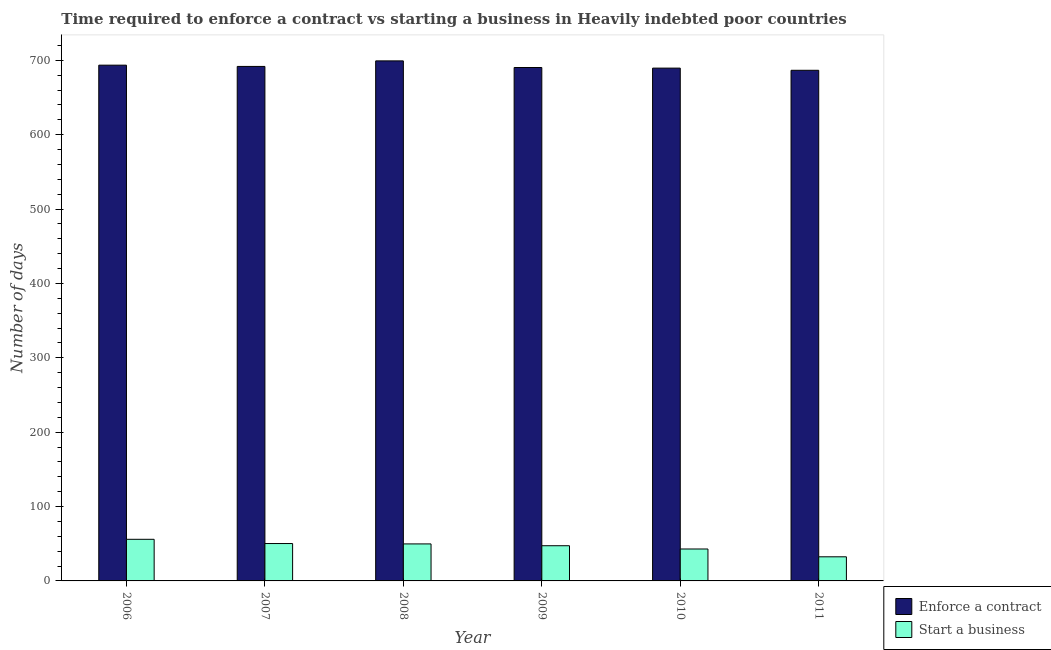How many different coloured bars are there?
Your response must be concise. 2. Are the number of bars per tick equal to the number of legend labels?
Provide a short and direct response. Yes. Are the number of bars on each tick of the X-axis equal?
Ensure brevity in your answer.  Yes. How many bars are there on the 2nd tick from the right?
Make the answer very short. 2. In how many cases, is the number of bars for a given year not equal to the number of legend labels?
Give a very brief answer. 0. What is the number of days to enforece a contract in 2007?
Ensure brevity in your answer.  691.74. Across all years, what is the maximum number of days to start a business?
Ensure brevity in your answer.  55.95. Across all years, what is the minimum number of days to start a business?
Your answer should be compact. 32.43. In which year was the number of days to start a business maximum?
Offer a terse response. 2006. What is the total number of days to enforece a contract in the graph?
Ensure brevity in your answer.  4150.71. What is the difference between the number of days to start a business in 2008 and that in 2009?
Provide a short and direct response. 2.45. What is the difference between the number of days to enforece a contract in 2010 and the number of days to start a business in 2007?
Provide a short and direct response. -2.26. What is the average number of days to start a business per year?
Make the answer very short. 46.44. In the year 2010, what is the difference between the number of days to enforece a contract and number of days to start a business?
Keep it short and to the point. 0. In how many years, is the number of days to enforece a contract greater than 140 days?
Ensure brevity in your answer.  6. What is the ratio of the number of days to enforece a contract in 2009 to that in 2011?
Provide a short and direct response. 1.01. Is the number of days to start a business in 2008 less than that in 2009?
Your answer should be compact. No. What is the difference between the highest and the second highest number of days to start a business?
Your answer should be very brief. 5.68. What is the difference between the highest and the lowest number of days to start a business?
Provide a succinct answer. 23.51. In how many years, is the number of days to enforece a contract greater than the average number of days to enforece a contract taken over all years?
Your response must be concise. 2. Is the sum of the number of days to start a business in 2008 and 2009 greater than the maximum number of days to enforece a contract across all years?
Your answer should be very brief. Yes. What does the 2nd bar from the left in 2010 represents?
Offer a very short reply. Start a business. What does the 2nd bar from the right in 2008 represents?
Ensure brevity in your answer.  Enforce a contract. How many bars are there?
Offer a very short reply. 12. Are all the bars in the graph horizontal?
Keep it short and to the point. No. How many years are there in the graph?
Your answer should be compact. 6. What is the difference between two consecutive major ticks on the Y-axis?
Ensure brevity in your answer.  100. Are the values on the major ticks of Y-axis written in scientific E-notation?
Offer a terse response. No. Where does the legend appear in the graph?
Ensure brevity in your answer.  Bottom right. How are the legend labels stacked?
Offer a terse response. Vertical. What is the title of the graph?
Keep it short and to the point. Time required to enforce a contract vs starting a business in Heavily indebted poor countries. Does "All education staff compensation" appear as one of the legend labels in the graph?
Offer a terse response. No. What is the label or title of the X-axis?
Your answer should be very brief. Year. What is the label or title of the Y-axis?
Provide a short and direct response. Number of days. What is the Number of days in Enforce a contract in 2006?
Your answer should be compact. 693.45. What is the Number of days of Start a business in 2006?
Your answer should be very brief. 55.95. What is the Number of days in Enforce a contract in 2007?
Provide a short and direct response. 691.74. What is the Number of days of Start a business in 2007?
Ensure brevity in your answer.  50.26. What is the Number of days in Enforce a contract in 2008?
Provide a succinct answer. 699.21. What is the Number of days of Start a business in 2008?
Your response must be concise. 49.76. What is the Number of days in Enforce a contract in 2009?
Ensure brevity in your answer.  690.29. What is the Number of days in Start a business in 2009?
Provide a succinct answer. 47.32. What is the Number of days in Enforce a contract in 2010?
Ensure brevity in your answer.  689.47. What is the Number of days in Start a business in 2010?
Your response must be concise. 42.92. What is the Number of days in Enforce a contract in 2011?
Make the answer very short. 686.55. What is the Number of days of Start a business in 2011?
Give a very brief answer. 32.43. Across all years, what is the maximum Number of days in Enforce a contract?
Your answer should be compact. 699.21. Across all years, what is the maximum Number of days of Start a business?
Ensure brevity in your answer.  55.95. Across all years, what is the minimum Number of days in Enforce a contract?
Ensure brevity in your answer.  686.55. Across all years, what is the minimum Number of days in Start a business?
Your answer should be compact. 32.43. What is the total Number of days of Enforce a contract in the graph?
Keep it short and to the point. 4150.71. What is the total Number of days of Start a business in the graph?
Ensure brevity in your answer.  278.64. What is the difference between the Number of days of Enforce a contract in 2006 and that in 2007?
Your response must be concise. 1.71. What is the difference between the Number of days of Start a business in 2006 and that in 2007?
Give a very brief answer. 5.68. What is the difference between the Number of days of Enforce a contract in 2006 and that in 2008?
Ensure brevity in your answer.  -5.76. What is the difference between the Number of days of Start a business in 2006 and that in 2008?
Provide a short and direct response. 6.18. What is the difference between the Number of days of Enforce a contract in 2006 and that in 2009?
Your answer should be very brief. 3.16. What is the difference between the Number of days in Start a business in 2006 and that in 2009?
Make the answer very short. 8.63. What is the difference between the Number of days of Enforce a contract in 2006 and that in 2010?
Provide a short and direct response. 3.97. What is the difference between the Number of days in Start a business in 2006 and that in 2010?
Offer a very short reply. 13.03. What is the difference between the Number of days in Enforce a contract in 2006 and that in 2011?
Give a very brief answer. 6.89. What is the difference between the Number of days of Start a business in 2006 and that in 2011?
Provide a succinct answer. 23.51. What is the difference between the Number of days of Enforce a contract in 2007 and that in 2008?
Keep it short and to the point. -7.47. What is the difference between the Number of days in Enforce a contract in 2007 and that in 2009?
Your answer should be very brief. 1.45. What is the difference between the Number of days of Start a business in 2007 and that in 2009?
Provide a succinct answer. 2.95. What is the difference between the Number of days of Enforce a contract in 2007 and that in 2010?
Provide a succinct answer. 2.26. What is the difference between the Number of days in Start a business in 2007 and that in 2010?
Offer a terse response. 7.34. What is the difference between the Number of days in Enforce a contract in 2007 and that in 2011?
Your answer should be compact. 5.18. What is the difference between the Number of days in Start a business in 2007 and that in 2011?
Ensure brevity in your answer.  17.83. What is the difference between the Number of days in Enforce a contract in 2008 and that in 2009?
Provide a succinct answer. 8.92. What is the difference between the Number of days of Start a business in 2008 and that in 2009?
Your answer should be very brief. 2.45. What is the difference between the Number of days of Enforce a contract in 2008 and that in 2010?
Offer a very short reply. 9.74. What is the difference between the Number of days of Start a business in 2008 and that in 2010?
Offer a very short reply. 6.84. What is the difference between the Number of days in Enforce a contract in 2008 and that in 2011?
Your answer should be compact. 12.66. What is the difference between the Number of days in Start a business in 2008 and that in 2011?
Offer a terse response. 17.33. What is the difference between the Number of days of Enforce a contract in 2009 and that in 2010?
Your answer should be very brief. 0.82. What is the difference between the Number of days of Start a business in 2009 and that in 2010?
Give a very brief answer. 4.39. What is the difference between the Number of days in Enforce a contract in 2009 and that in 2011?
Your answer should be compact. 3.74. What is the difference between the Number of days in Start a business in 2009 and that in 2011?
Your response must be concise. 14.88. What is the difference between the Number of days of Enforce a contract in 2010 and that in 2011?
Ensure brevity in your answer.  2.92. What is the difference between the Number of days in Start a business in 2010 and that in 2011?
Your answer should be compact. 10.49. What is the difference between the Number of days in Enforce a contract in 2006 and the Number of days in Start a business in 2007?
Offer a terse response. 643.18. What is the difference between the Number of days in Enforce a contract in 2006 and the Number of days in Start a business in 2008?
Ensure brevity in your answer.  643.68. What is the difference between the Number of days of Enforce a contract in 2006 and the Number of days of Start a business in 2009?
Your answer should be very brief. 646.13. What is the difference between the Number of days of Enforce a contract in 2006 and the Number of days of Start a business in 2010?
Your response must be concise. 650.53. What is the difference between the Number of days of Enforce a contract in 2006 and the Number of days of Start a business in 2011?
Your answer should be very brief. 661.01. What is the difference between the Number of days in Enforce a contract in 2007 and the Number of days in Start a business in 2008?
Your response must be concise. 641.97. What is the difference between the Number of days of Enforce a contract in 2007 and the Number of days of Start a business in 2009?
Your response must be concise. 644.42. What is the difference between the Number of days in Enforce a contract in 2007 and the Number of days in Start a business in 2010?
Offer a terse response. 648.82. What is the difference between the Number of days of Enforce a contract in 2007 and the Number of days of Start a business in 2011?
Make the answer very short. 659.3. What is the difference between the Number of days of Enforce a contract in 2008 and the Number of days of Start a business in 2009?
Offer a terse response. 651.89. What is the difference between the Number of days of Enforce a contract in 2008 and the Number of days of Start a business in 2010?
Your answer should be very brief. 656.29. What is the difference between the Number of days in Enforce a contract in 2008 and the Number of days in Start a business in 2011?
Offer a very short reply. 666.78. What is the difference between the Number of days of Enforce a contract in 2009 and the Number of days of Start a business in 2010?
Provide a short and direct response. 647.37. What is the difference between the Number of days of Enforce a contract in 2009 and the Number of days of Start a business in 2011?
Give a very brief answer. 657.86. What is the difference between the Number of days of Enforce a contract in 2010 and the Number of days of Start a business in 2011?
Make the answer very short. 657.04. What is the average Number of days of Enforce a contract per year?
Give a very brief answer. 691.79. What is the average Number of days of Start a business per year?
Make the answer very short. 46.44. In the year 2006, what is the difference between the Number of days in Enforce a contract and Number of days in Start a business?
Your answer should be compact. 637.5. In the year 2007, what is the difference between the Number of days of Enforce a contract and Number of days of Start a business?
Your answer should be very brief. 641.47. In the year 2008, what is the difference between the Number of days in Enforce a contract and Number of days in Start a business?
Provide a succinct answer. 649.45. In the year 2009, what is the difference between the Number of days of Enforce a contract and Number of days of Start a business?
Offer a very short reply. 642.97. In the year 2010, what is the difference between the Number of days of Enforce a contract and Number of days of Start a business?
Offer a very short reply. 646.55. In the year 2011, what is the difference between the Number of days in Enforce a contract and Number of days in Start a business?
Offer a terse response. 654.12. What is the ratio of the Number of days of Enforce a contract in 2006 to that in 2007?
Keep it short and to the point. 1. What is the ratio of the Number of days of Start a business in 2006 to that in 2007?
Make the answer very short. 1.11. What is the ratio of the Number of days of Start a business in 2006 to that in 2008?
Provide a short and direct response. 1.12. What is the ratio of the Number of days of Enforce a contract in 2006 to that in 2009?
Your answer should be very brief. 1. What is the ratio of the Number of days of Start a business in 2006 to that in 2009?
Offer a terse response. 1.18. What is the ratio of the Number of days in Enforce a contract in 2006 to that in 2010?
Offer a terse response. 1.01. What is the ratio of the Number of days of Start a business in 2006 to that in 2010?
Provide a succinct answer. 1.3. What is the ratio of the Number of days in Start a business in 2006 to that in 2011?
Your answer should be compact. 1.72. What is the ratio of the Number of days in Enforce a contract in 2007 to that in 2008?
Your answer should be compact. 0.99. What is the ratio of the Number of days in Start a business in 2007 to that in 2008?
Provide a short and direct response. 1.01. What is the ratio of the Number of days of Enforce a contract in 2007 to that in 2009?
Your response must be concise. 1. What is the ratio of the Number of days of Start a business in 2007 to that in 2009?
Provide a short and direct response. 1.06. What is the ratio of the Number of days in Enforce a contract in 2007 to that in 2010?
Your answer should be compact. 1. What is the ratio of the Number of days of Start a business in 2007 to that in 2010?
Provide a succinct answer. 1.17. What is the ratio of the Number of days in Enforce a contract in 2007 to that in 2011?
Offer a very short reply. 1.01. What is the ratio of the Number of days of Start a business in 2007 to that in 2011?
Your response must be concise. 1.55. What is the ratio of the Number of days in Enforce a contract in 2008 to that in 2009?
Give a very brief answer. 1.01. What is the ratio of the Number of days in Start a business in 2008 to that in 2009?
Your answer should be compact. 1.05. What is the ratio of the Number of days in Enforce a contract in 2008 to that in 2010?
Your answer should be compact. 1.01. What is the ratio of the Number of days in Start a business in 2008 to that in 2010?
Make the answer very short. 1.16. What is the ratio of the Number of days of Enforce a contract in 2008 to that in 2011?
Keep it short and to the point. 1.02. What is the ratio of the Number of days in Start a business in 2008 to that in 2011?
Keep it short and to the point. 1.53. What is the ratio of the Number of days in Enforce a contract in 2009 to that in 2010?
Give a very brief answer. 1. What is the ratio of the Number of days in Start a business in 2009 to that in 2010?
Provide a succinct answer. 1.1. What is the ratio of the Number of days of Enforce a contract in 2009 to that in 2011?
Your answer should be very brief. 1.01. What is the ratio of the Number of days of Start a business in 2009 to that in 2011?
Provide a short and direct response. 1.46. What is the ratio of the Number of days of Enforce a contract in 2010 to that in 2011?
Your answer should be compact. 1. What is the ratio of the Number of days in Start a business in 2010 to that in 2011?
Your answer should be compact. 1.32. What is the difference between the highest and the second highest Number of days in Enforce a contract?
Provide a succinct answer. 5.76. What is the difference between the highest and the second highest Number of days in Start a business?
Your answer should be very brief. 5.68. What is the difference between the highest and the lowest Number of days of Enforce a contract?
Make the answer very short. 12.66. What is the difference between the highest and the lowest Number of days in Start a business?
Your answer should be compact. 23.51. 